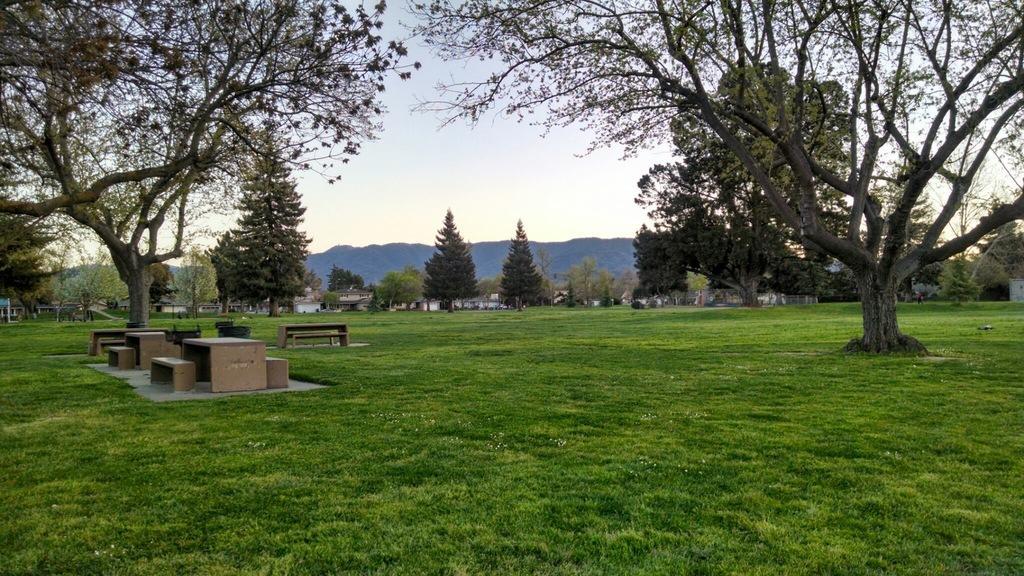Describe this image in one or two sentences. In this picture there are buildings and trees and there are mountains. In the foreground there are tables and benches. At the top there is sky. At the bottom there is grass. 